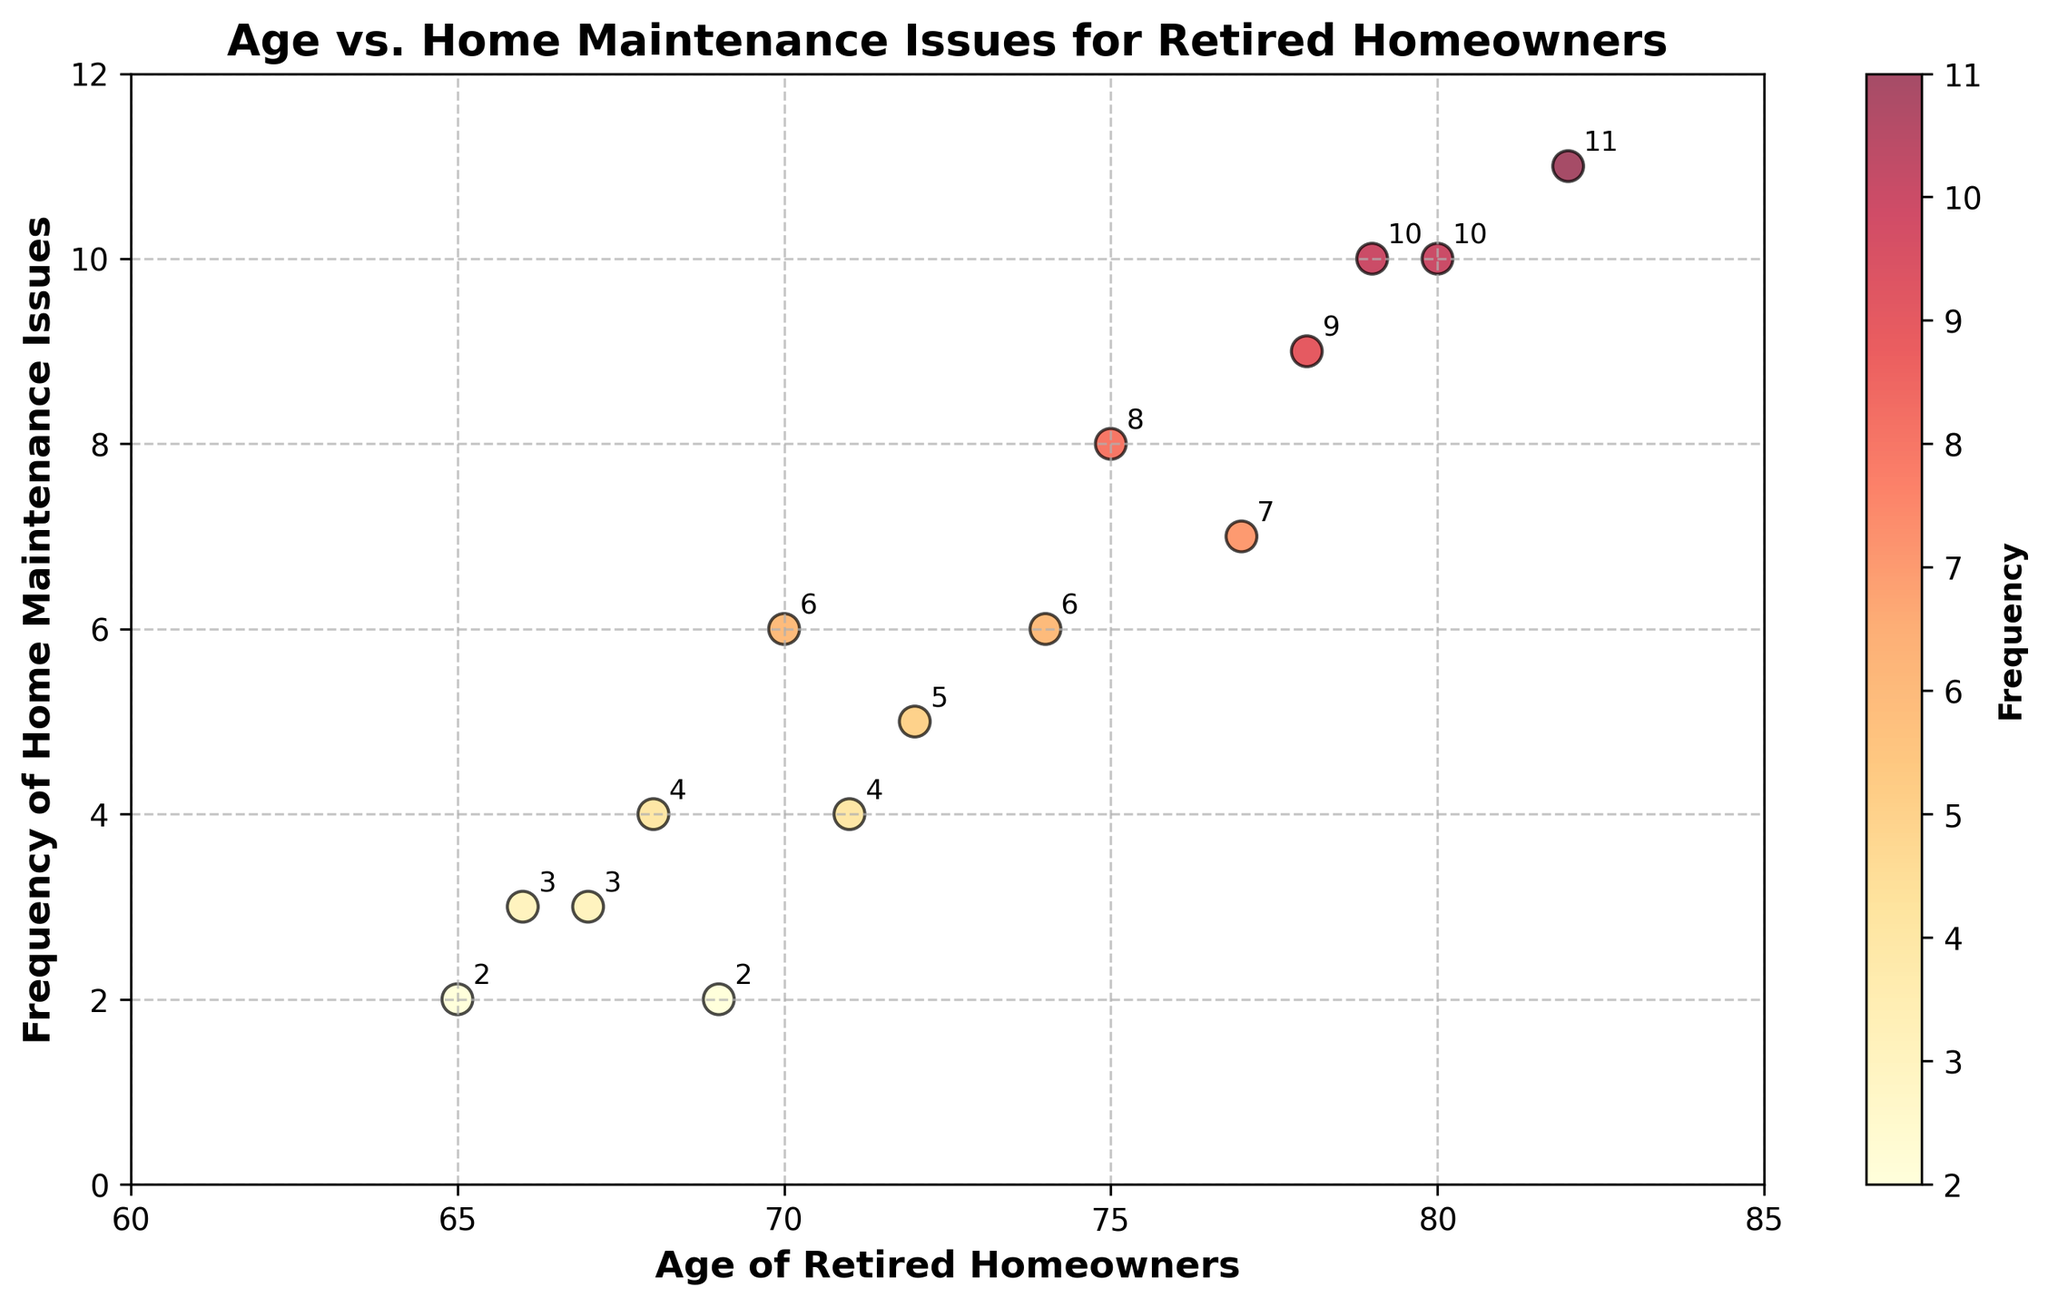What's the title of the figure? The title is clearly displayed at the top of the figure. It reads "Age vs. Home Maintenance Issues for Retired Homeowners".
Answer: Age vs. Home Maintenance Issues for Retired Homeowners How many data points are plotted in the figure? By visually counting the number of dots in the scatter plot, we can determine there are 15 data points.
Answer: 15 What are the x-axis and y-axis labels? The x-axis label is "Age of Retired Homeowners" and the y-axis label is "Frequency of Home Maintenance Issues". These labels are clearly shown next to the respective axes.
Answer: Age of Retired Homeowners, Frequency of Home Maintenance Issues What is the frequency of home maintenance issues for the 80-year-old homeowner? By locating the point where the age is 80 on the x-axis and observing its corresponding y-value, we see that the frequency is 10.
Answer: 10 Which homeowner age has the highest frequency of home maintenance issues? By looking at the y-values on the scatter plot, the highest frequency is 11. This value corresponds to the homeowner aged 82.
Answer: 82 Are there more homeowners with frequencies of home maintenance issues above or below 5? By counting the number of points above and below the y-value of 5, we find there are 6 points below and 9 points above.
Answer: Above What is the average frequency of home maintenance issues for homeowners aged 75 and older? First, identify the y-values for homeowners aged 75 and older: 8, 10, 7, 9, 10, and 11. Then calculate the average: (8 + 10 + 7 + 9 + 10 + 11) / 6 = 55 / 6 ≈ 9.17.
Answer: 9.17 Compare the frequency of home maintenance issues for homeowners aged 67 and 77. Which age group has a higher frequency? The y-value for age 67 is 3 and for age 77 is 7. By comparing these values, we see that homeowners aged 77 have a higher frequency.
Answer: 77 What is the difference in the frequency of home maintenance issues between the homeowners aged 70 and 69? The frequency for age 70 is 6, and for age 69 it is 2. The difference is 6 - 2 = 4.
Answer: 4 What trend can you observe between the age of retired homeowners and the frequency of home maintenance issues? The scatter plot shows that as the age of retired homeowners increases, the frequency of home maintenance issues tends to increase as well. This indicates a positive correlation between age and maintenance issues.
Answer: Positive correlation 